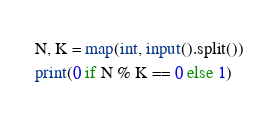<code> <loc_0><loc_0><loc_500><loc_500><_Python_>N, K = map(int, input().split())
print(0 if N % K == 0 else 1)
</code> 